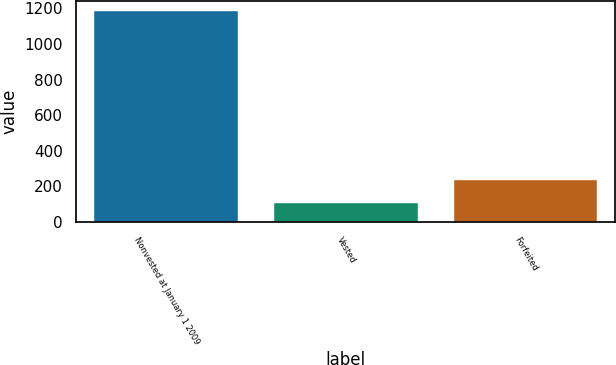Convert chart. <chart><loc_0><loc_0><loc_500><loc_500><bar_chart><fcel>Nonvested at January 1 2009<fcel>Vested<fcel>Forfeited<nl><fcel>1183<fcel>109<fcel>236<nl></chart> 